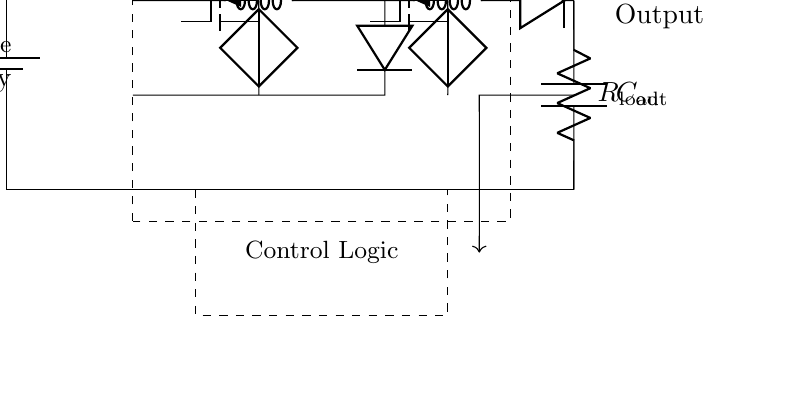What is the load resistance in the circuit? The load resistance is represented by R_load, which is labeled directly in the circuit diagram.
Answer: R_load What components are used for energy storage? The energy storage components are the inductor L_1, inductor L_2, and capacitor C_out, which are all labeled in the circuit.
Answer: L_1, L_2, C_out What is the role of the power management IC? The power management IC regulates the voltage and current for efficient power usage, as indicated by its central positioning in the circuit and the label.
Answer: Regulates voltage and current How many inductors are present in the circuit? There are two inductors labeled L_1 and L_2, which can be counted from the diagram.
Answer: 2 What type of converters are implemented in the circuit? The circuit uses a buck converter (for stepping down voltage) and a boost converter (for stepping up voltage), both indicated with their corresponding components in the diagram.
Answer: Buck and boost converters What is the function of the control logic section? The control logic manages the operational modes of the converters based on the feedback it receives, which is shown in the dashed rectangle in the circuit.
Answer: Manages operational modes What does the feedback line to control logic indicate? The feedback line provides information about the output voltage to control the functioning of the converters, ensuring they adjust properly based on load conditions.
Answer: Output voltage information 